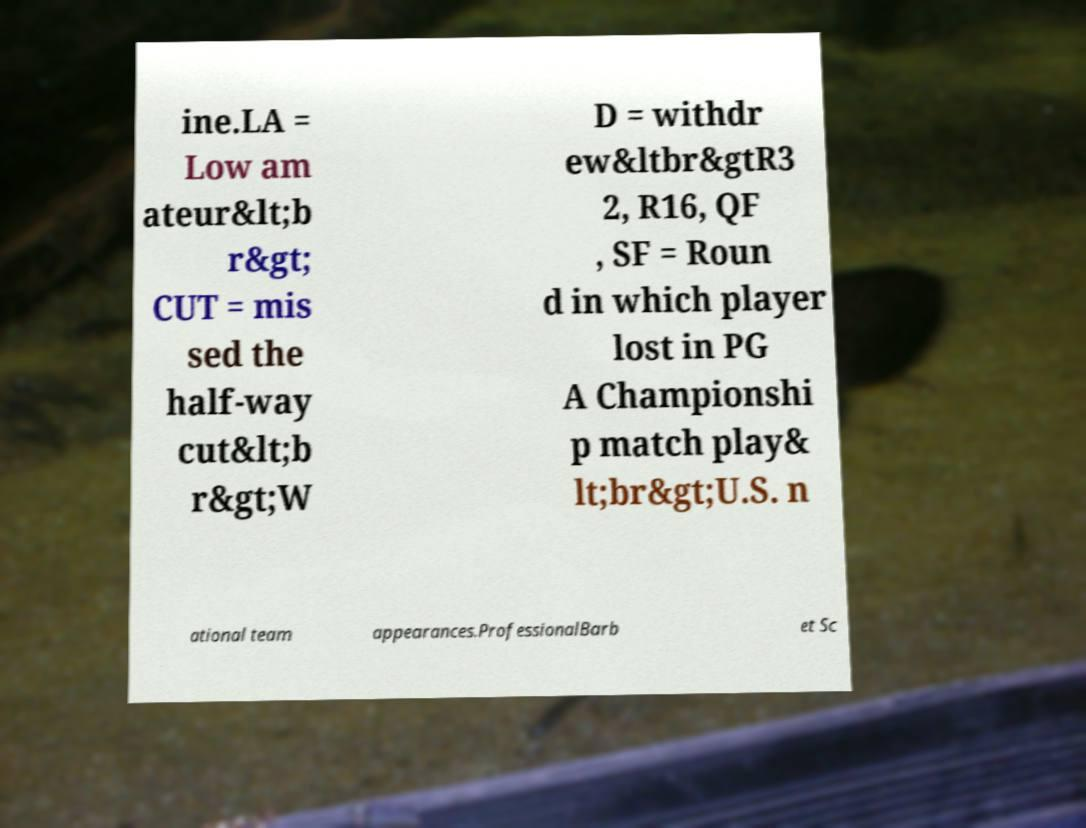Please read and relay the text visible in this image. What does it say? ine.LA = Low am ateur&lt;b r&gt; CUT = mis sed the half-way cut&lt;b r&gt;W D = withdr ew&ltbr&gtR3 2, R16, QF , SF = Roun d in which player lost in PG A Championshi p match play& lt;br&gt;U.S. n ational team appearances.ProfessionalBarb et Sc 